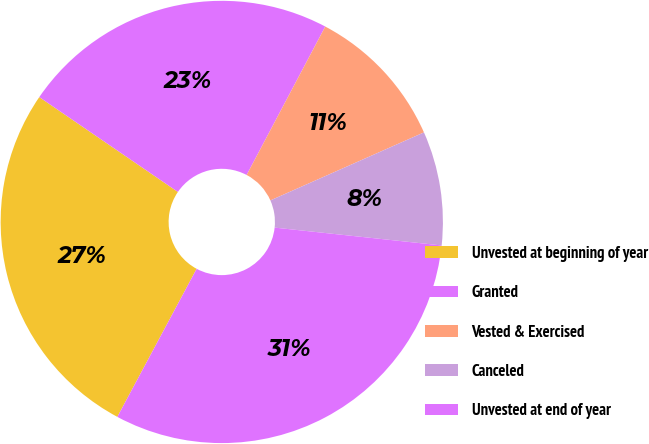Convert chart. <chart><loc_0><loc_0><loc_500><loc_500><pie_chart><fcel>Unvested at beginning of year<fcel>Granted<fcel>Vested & Exercised<fcel>Canceled<fcel>Unvested at end of year<nl><fcel>26.72%<fcel>23.2%<fcel>10.61%<fcel>8.33%<fcel>31.13%<nl></chart> 